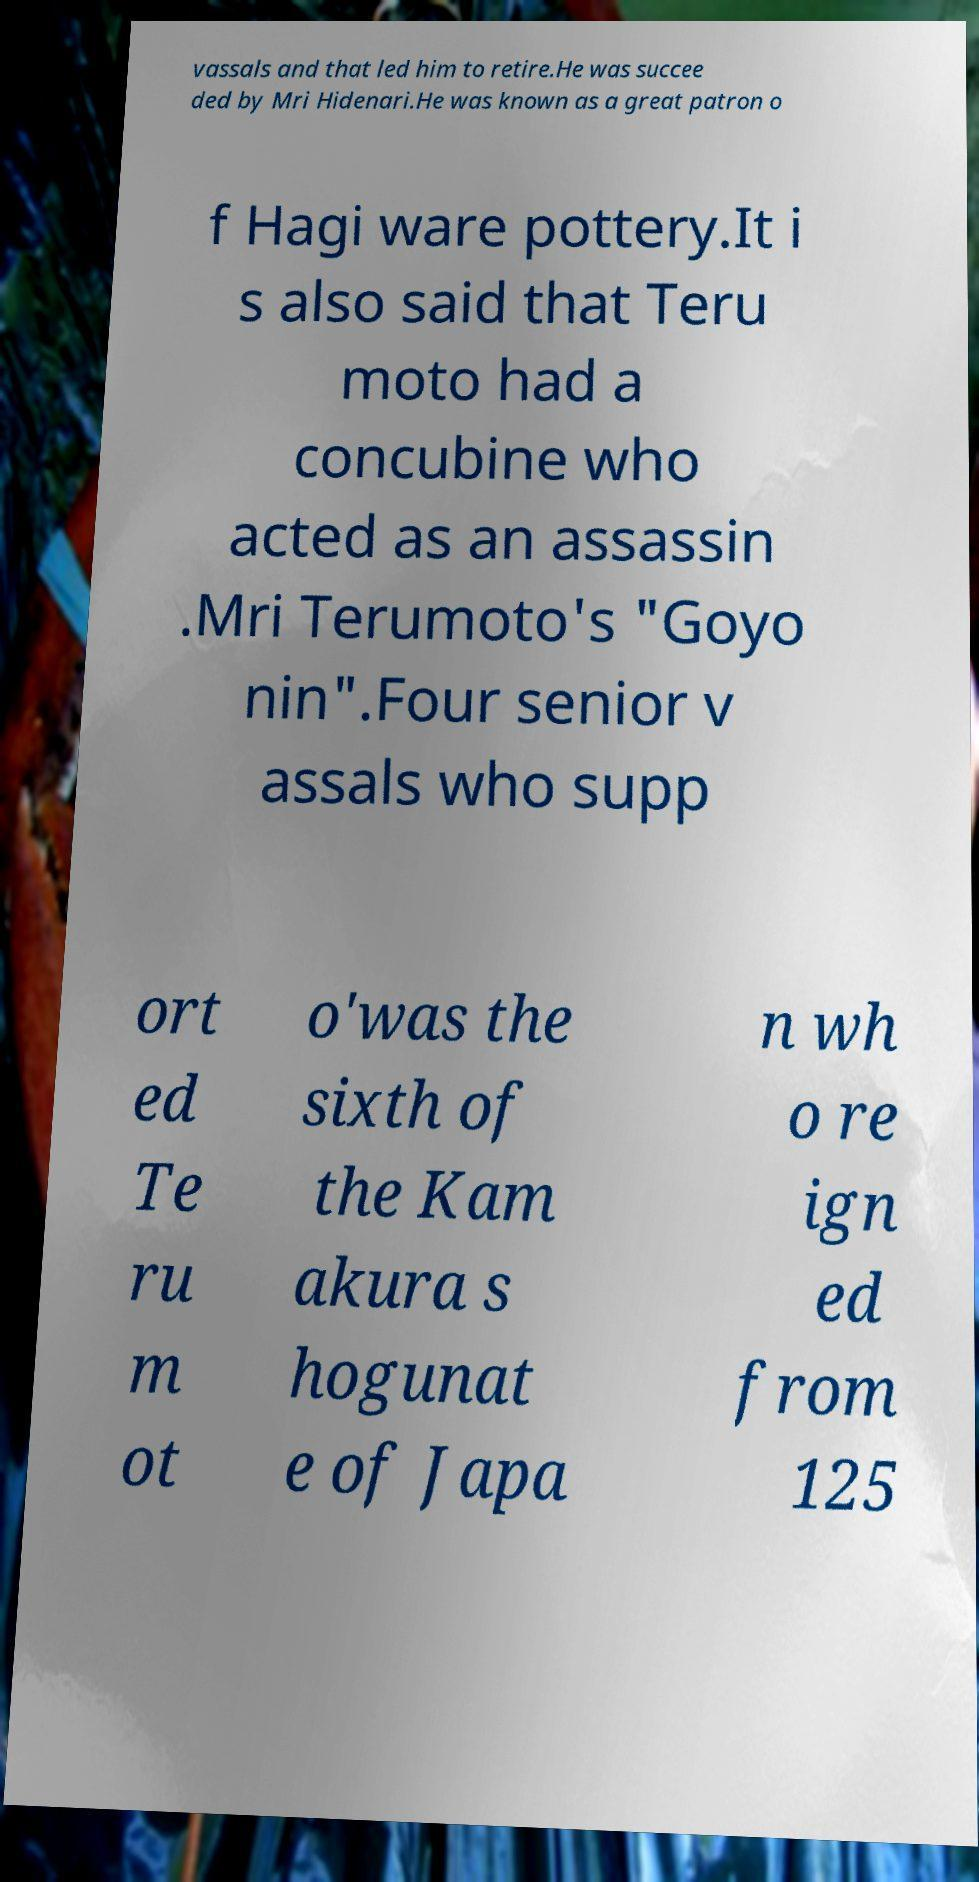Can you accurately transcribe the text from the provided image for me? vassals and that led him to retire.He was succee ded by Mri Hidenari.He was known as a great patron o f Hagi ware pottery.It i s also said that Teru moto had a concubine who acted as an assassin .Mri Terumoto's "Goyo nin".Four senior v assals who supp ort ed Te ru m ot o'was the sixth of the Kam akura s hogunat e of Japa n wh o re ign ed from 125 